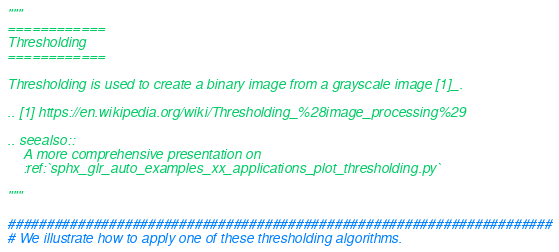<code> <loc_0><loc_0><loc_500><loc_500><_Python_>"""
============
Thresholding
============

Thresholding is used to create a binary image from a grayscale image [1]_.

.. [1] https://en.wikipedia.org/wiki/Thresholding_%28image_processing%29

.. seealso::
    A more comprehensive presentation on
    :ref:`sphx_glr_auto_examples_xx_applications_plot_thresholding.py`

"""

######################################################################
# We illustrate how to apply one of these thresholding algorithms.</code> 